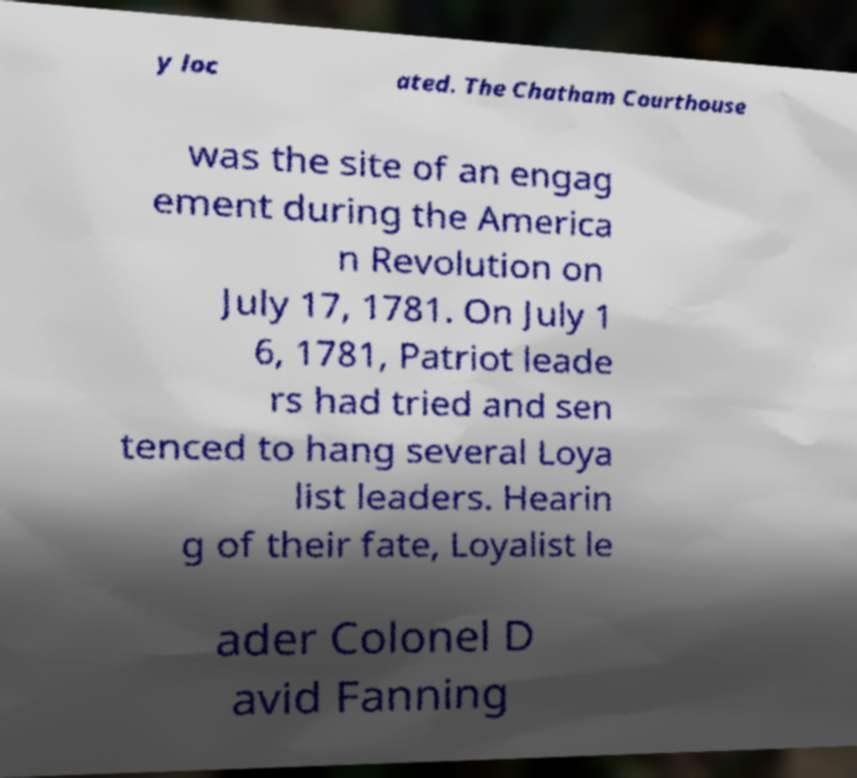Please read and relay the text visible in this image. What does it say? y loc ated. The Chatham Courthouse was the site of an engag ement during the America n Revolution on July 17, 1781. On July 1 6, 1781, Patriot leade rs had tried and sen tenced to hang several Loya list leaders. Hearin g of their fate, Loyalist le ader Colonel D avid Fanning 